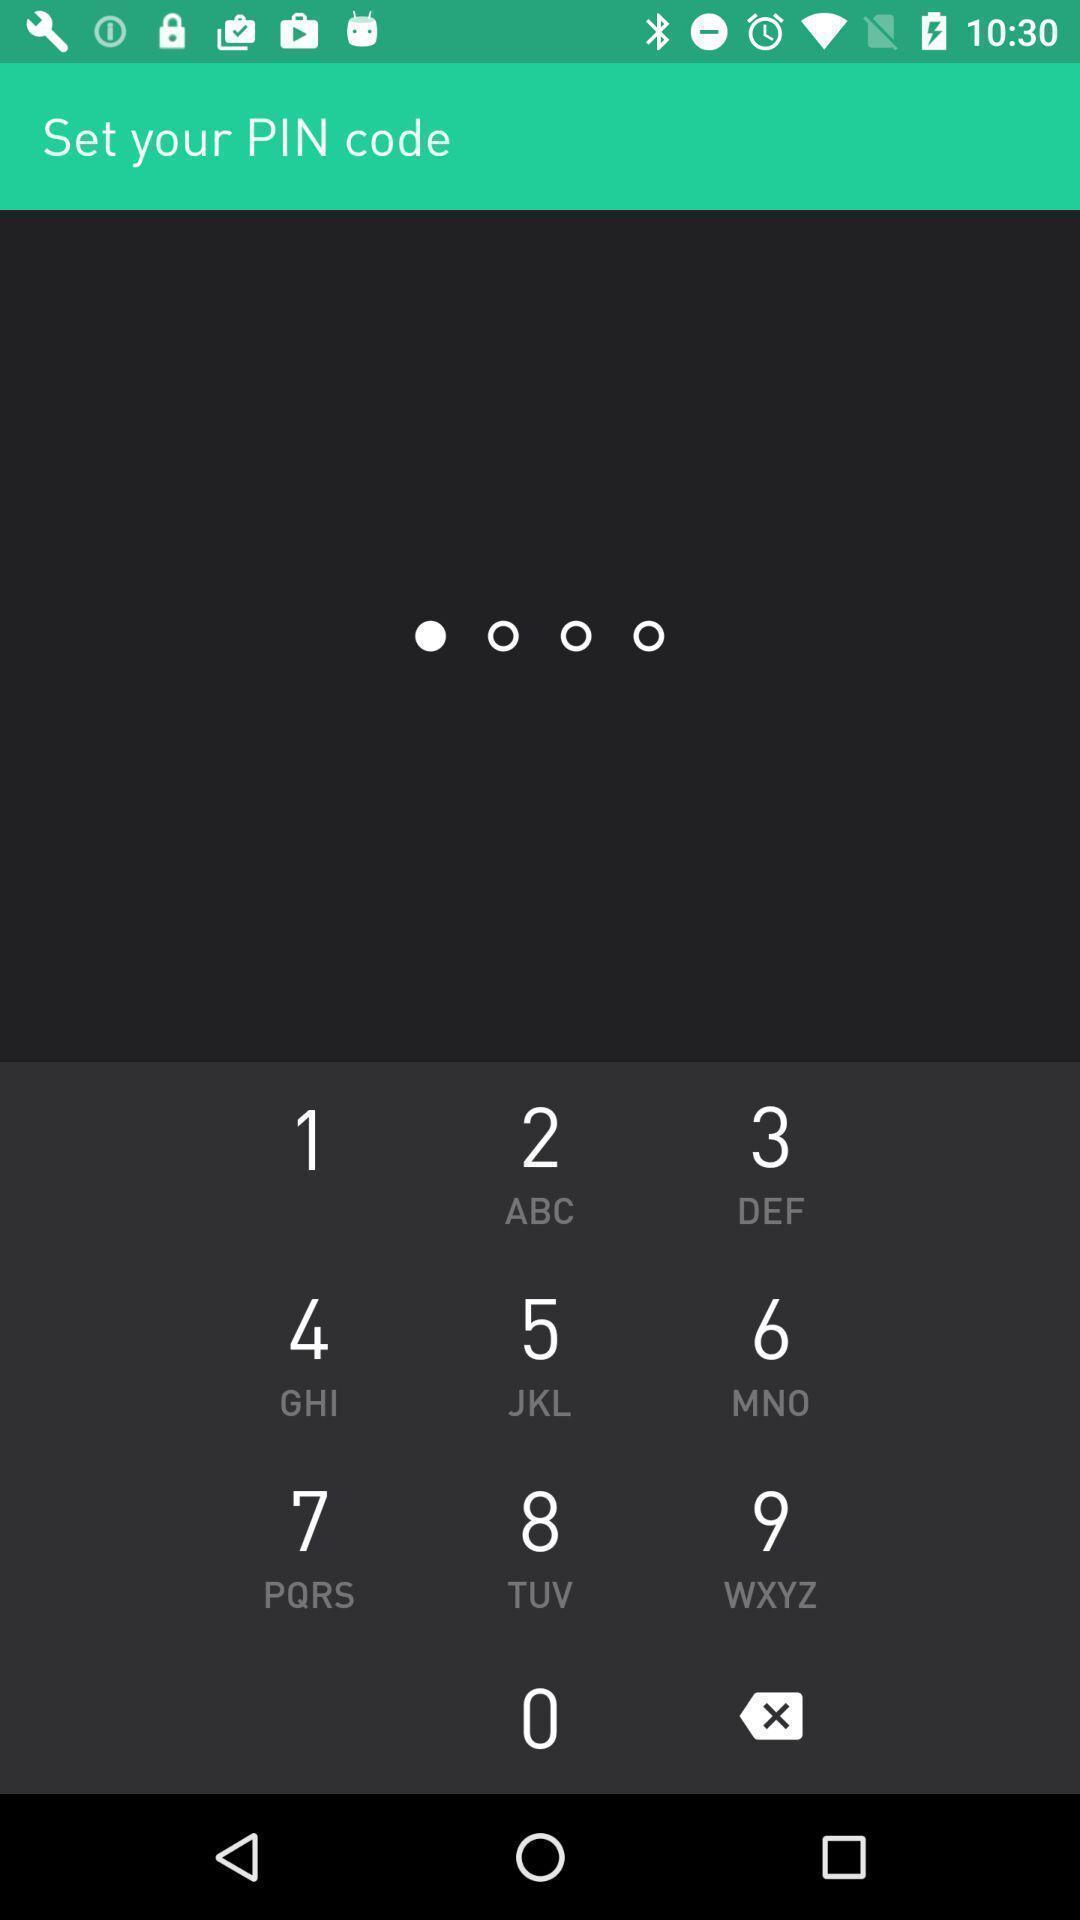Provide a detailed account of this screenshot. Setting a pin code for the app. 